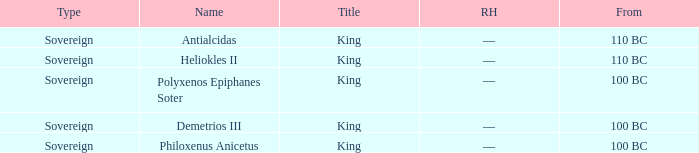When did Demetrios III begin to hold power? 100 BC. 